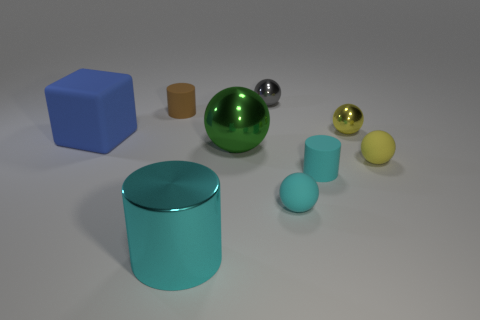Can you tell me which objects have the same color but different shapes? In the image, the tall cylinder and the smaller spherical object both share a similar shade of cyan but differ significantly in shape; one is cylindrical while the other is spherical.  Are there any patterns or symmetries in the arrangement of the objects? The objects are arranged without a clear pattern or symmetry. They are placed at varying distances apart and the assortment of shapes and colors appears random rather than organized. 